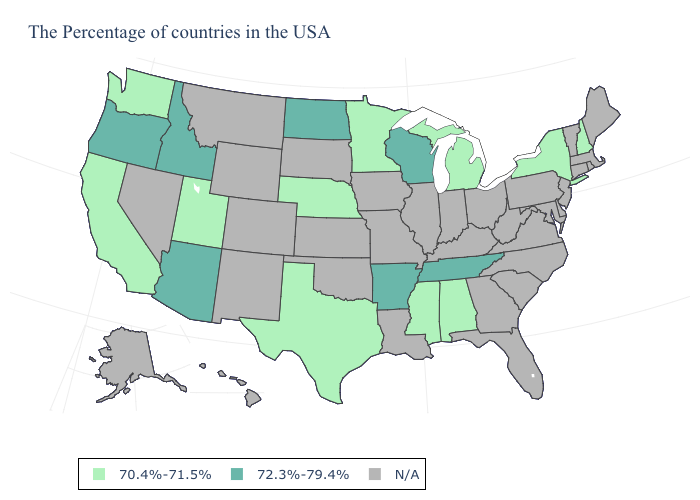Is the legend a continuous bar?
Give a very brief answer. No. Which states have the lowest value in the USA?
Give a very brief answer. New Hampshire, New York, Michigan, Alabama, Mississippi, Minnesota, Nebraska, Texas, Utah, California, Washington. Name the states that have a value in the range 72.3%-79.4%?
Give a very brief answer. Tennessee, Wisconsin, Arkansas, North Dakota, Arizona, Idaho, Oregon. Name the states that have a value in the range 70.4%-71.5%?
Be succinct. New Hampshire, New York, Michigan, Alabama, Mississippi, Minnesota, Nebraska, Texas, Utah, California, Washington. Does Alabama have the highest value in the South?
Concise answer only. No. Does Arizona have the highest value in the USA?
Quick response, please. Yes. What is the value of Ohio?
Give a very brief answer. N/A. Does the first symbol in the legend represent the smallest category?
Write a very short answer. Yes. What is the value of Georgia?
Be succinct. N/A. Name the states that have a value in the range N/A?
Give a very brief answer. Maine, Massachusetts, Rhode Island, Vermont, Connecticut, New Jersey, Delaware, Maryland, Pennsylvania, Virginia, North Carolina, South Carolina, West Virginia, Ohio, Florida, Georgia, Kentucky, Indiana, Illinois, Louisiana, Missouri, Iowa, Kansas, Oklahoma, South Dakota, Wyoming, Colorado, New Mexico, Montana, Nevada, Alaska, Hawaii. Does Michigan have the lowest value in the MidWest?
Concise answer only. Yes. Among the states that border Nevada , does Utah have the lowest value?
Quick response, please. Yes. Which states hav the highest value in the South?
Short answer required. Tennessee, Arkansas. 